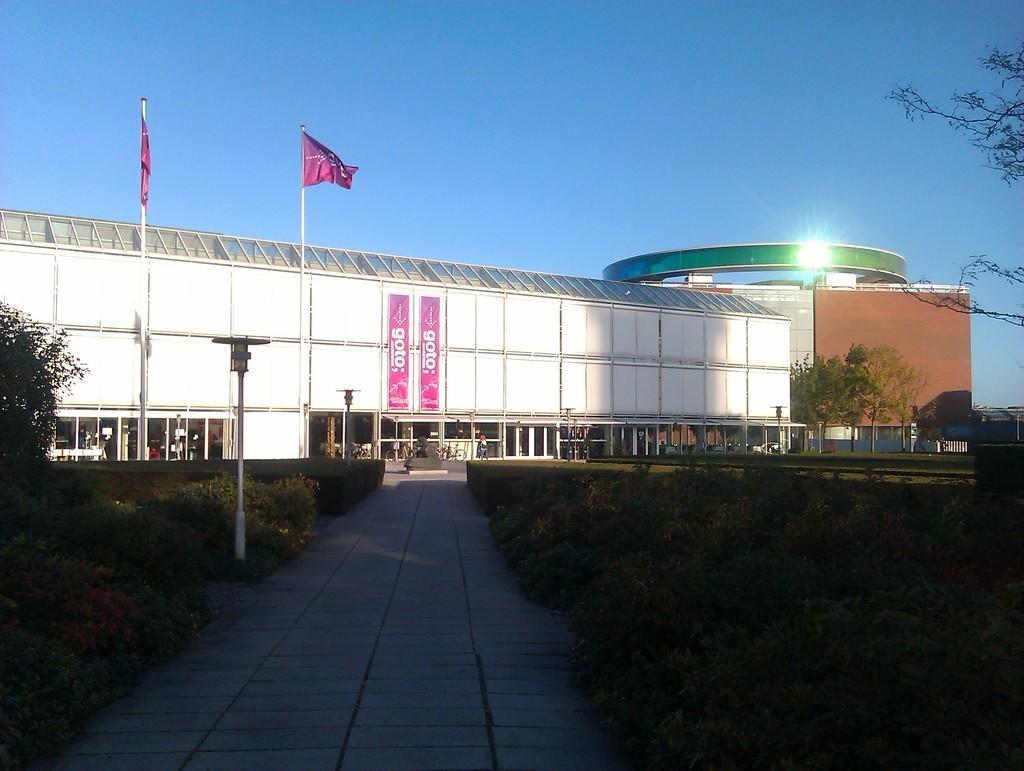In one or two sentences, can you explain what this image depicts? In this picture I can see the path in the center and I see the plants on both the sides. In the middle of this picture I can see the buildings, few poles and 2 flags. I can also see few trees. In the background I can see the sky. 